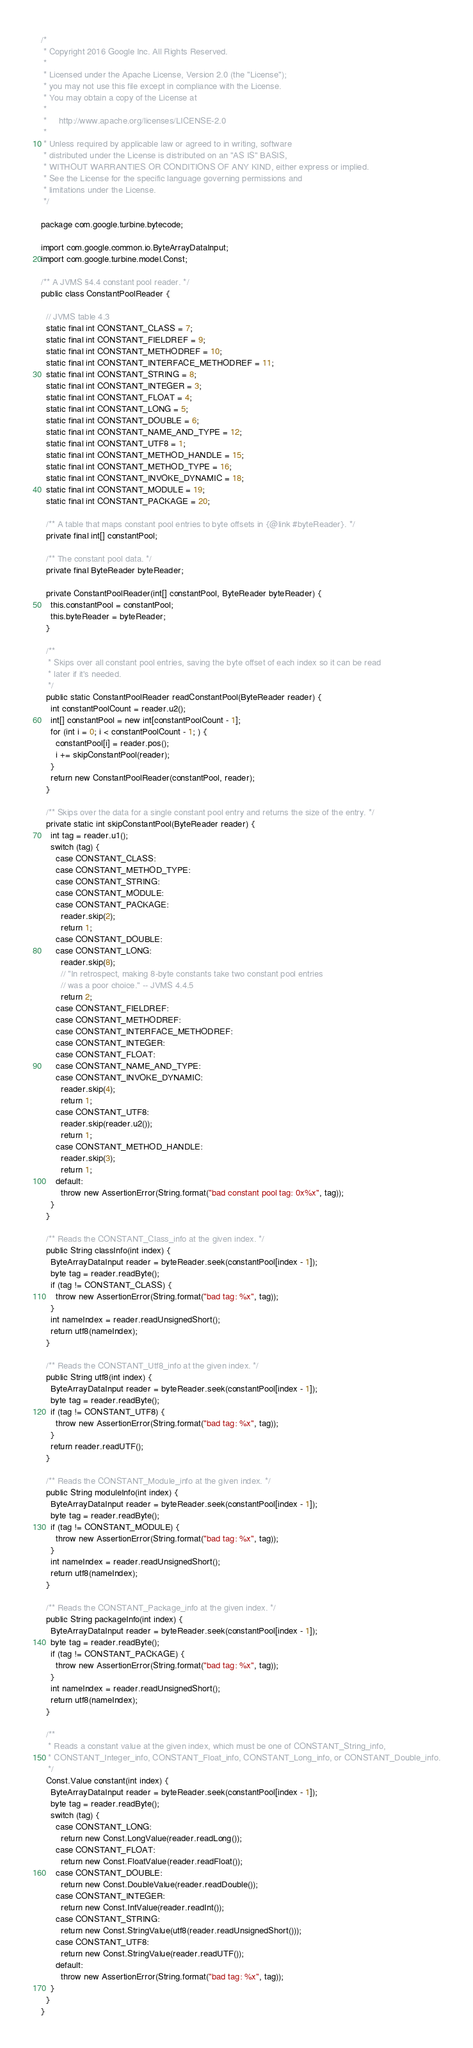Convert code to text. <code><loc_0><loc_0><loc_500><loc_500><_Java_>/*
 * Copyright 2016 Google Inc. All Rights Reserved.
 *
 * Licensed under the Apache License, Version 2.0 (the "License");
 * you may not use this file except in compliance with the License.
 * You may obtain a copy of the License at
 *
 *     http://www.apache.org/licenses/LICENSE-2.0
 *
 * Unless required by applicable law or agreed to in writing, software
 * distributed under the License is distributed on an "AS IS" BASIS,
 * WITHOUT WARRANTIES OR CONDITIONS OF ANY KIND, either express or implied.
 * See the License for the specific language governing permissions and
 * limitations under the License.
 */

package com.google.turbine.bytecode;

import com.google.common.io.ByteArrayDataInput;
import com.google.turbine.model.Const;

/** A JVMS §4.4 constant pool reader. */
public class ConstantPoolReader {

  // JVMS table 4.3
  static final int CONSTANT_CLASS = 7;
  static final int CONSTANT_FIELDREF = 9;
  static final int CONSTANT_METHODREF = 10;
  static final int CONSTANT_INTERFACE_METHODREF = 11;
  static final int CONSTANT_STRING = 8;
  static final int CONSTANT_INTEGER = 3;
  static final int CONSTANT_FLOAT = 4;
  static final int CONSTANT_LONG = 5;
  static final int CONSTANT_DOUBLE = 6;
  static final int CONSTANT_NAME_AND_TYPE = 12;
  static final int CONSTANT_UTF8 = 1;
  static final int CONSTANT_METHOD_HANDLE = 15;
  static final int CONSTANT_METHOD_TYPE = 16;
  static final int CONSTANT_INVOKE_DYNAMIC = 18;
  static final int CONSTANT_MODULE = 19;
  static final int CONSTANT_PACKAGE = 20;

  /** A table that maps constant pool entries to byte offsets in {@link #byteReader}. */
  private final int[] constantPool;

  /** The constant pool data. */
  private final ByteReader byteReader;

  private ConstantPoolReader(int[] constantPool, ByteReader byteReader) {
    this.constantPool = constantPool;
    this.byteReader = byteReader;
  }

  /**
   * Skips over all constant pool entries, saving the byte offset of each index so it can be read
   * later if it's needed.
   */
  public static ConstantPoolReader readConstantPool(ByteReader reader) {
    int constantPoolCount = reader.u2();
    int[] constantPool = new int[constantPoolCount - 1];
    for (int i = 0; i < constantPoolCount - 1; ) {
      constantPool[i] = reader.pos();
      i += skipConstantPool(reader);
    }
    return new ConstantPoolReader(constantPool, reader);
  }

  /** Skips over the data for a single constant pool entry and returns the size of the entry. */
  private static int skipConstantPool(ByteReader reader) {
    int tag = reader.u1();
    switch (tag) {
      case CONSTANT_CLASS:
      case CONSTANT_METHOD_TYPE:
      case CONSTANT_STRING:
      case CONSTANT_MODULE:
      case CONSTANT_PACKAGE:
        reader.skip(2);
        return 1;
      case CONSTANT_DOUBLE:
      case CONSTANT_LONG:
        reader.skip(8);
        // "In retrospect, making 8-byte constants take two constant pool entries
        // was a poor choice." -- JVMS 4.4.5
        return 2;
      case CONSTANT_FIELDREF:
      case CONSTANT_METHODREF:
      case CONSTANT_INTERFACE_METHODREF:
      case CONSTANT_INTEGER:
      case CONSTANT_FLOAT:
      case CONSTANT_NAME_AND_TYPE:
      case CONSTANT_INVOKE_DYNAMIC:
        reader.skip(4);
        return 1;
      case CONSTANT_UTF8:
        reader.skip(reader.u2());
        return 1;
      case CONSTANT_METHOD_HANDLE:
        reader.skip(3);
        return 1;
      default:
        throw new AssertionError(String.format("bad constant pool tag: 0x%x", tag));
    }
  }

  /** Reads the CONSTANT_Class_info at the given index. */
  public String classInfo(int index) {
    ByteArrayDataInput reader = byteReader.seek(constantPool[index - 1]);
    byte tag = reader.readByte();
    if (tag != CONSTANT_CLASS) {
      throw new AssertionError(String.format("bad tag: %x", tag));
    }
    int nameIndex = reader.readUnsignedShort();
    return utf8(nameIndex);
  }

  /** Reads the CONSTANT_Utf8_info at the given index. */
  public String utf8(int index) {
    ByteArrayDataInput reader = byteReader.seek(constantPool[index - 1]);
    byte tag = reader.readByte();
    if (tag != CONSTANT_UTF8) {
      throw new AssertionError(String.format("bad tag: %x", tag));
    }
    return reader.readUTF();
  }

  /** Reads the CONSTANT_Module_info at the given index. */
  public String moduleInfo(int index) {
    ByteArrayDataInput reader = byteReader.seek(constantPool[index - 1]);
    byte tag = reader.readByte();
    if (tag != CONSTANT_MODULE) {
      throw new AssertionError(String.format("bad tag: %x", tag));
    }
    int nameIndex = reader.readUnsignedShort();
    return utf8(nameIndex);
  }

  /** Reads the CONSTANT_Package_info at the given index. */
  public String packageInfo(int index) {
    ByteArrayDataInput reader = byteReader.seek(constantPool[index - 1]);
    byte tag = reader.readByte();
    if (tag != CONSTANT_PACKAGE) {
      throw new AssertionError(String.format("bad tag: %x", tag));
    }
    int nameIndex = reader.readUnsignedShort();
    return utf8(nameIndex);
  }

  /**
   * Reads a constant value at the given index, which must be one of CONSTANT_String_info,
   * CONSTANT_Integer_info, CONSTANT_Float_info, CONSTANT_Long_info, or CONSTANT_Double_info.
   */
  Const.Value constant(int index) {
    ByteArrayDataInput reader = byteReader.seek(constantPool[index - 1]);
    byte tag = reader.readByte();
    switch (tag) {
      case CONSTANT_LONG:
        return new Const.LongValue(reader.readLong());
      case CONSTANT_FLOAT:
        return new Const.FloatValue(reader.readFloat());
      case CONSTANT_DOUBLE:
        return new Const.DoubleValue(reader.readDouble());
      case CONSTANT_INTEGER:
        return new Const.IntValue(reader.readInt());
      case CONSTANT_STRING:
        return new Const.StringValue(utf8(reader.readUnsignedShort()));
      case CONSTANT_UTF8:
        return new Const.StringValue(reader.readUTF());
      default:
        throw new AssertionError(String.format("bad tag: %x", tag));
    }
  }
}
</code> 